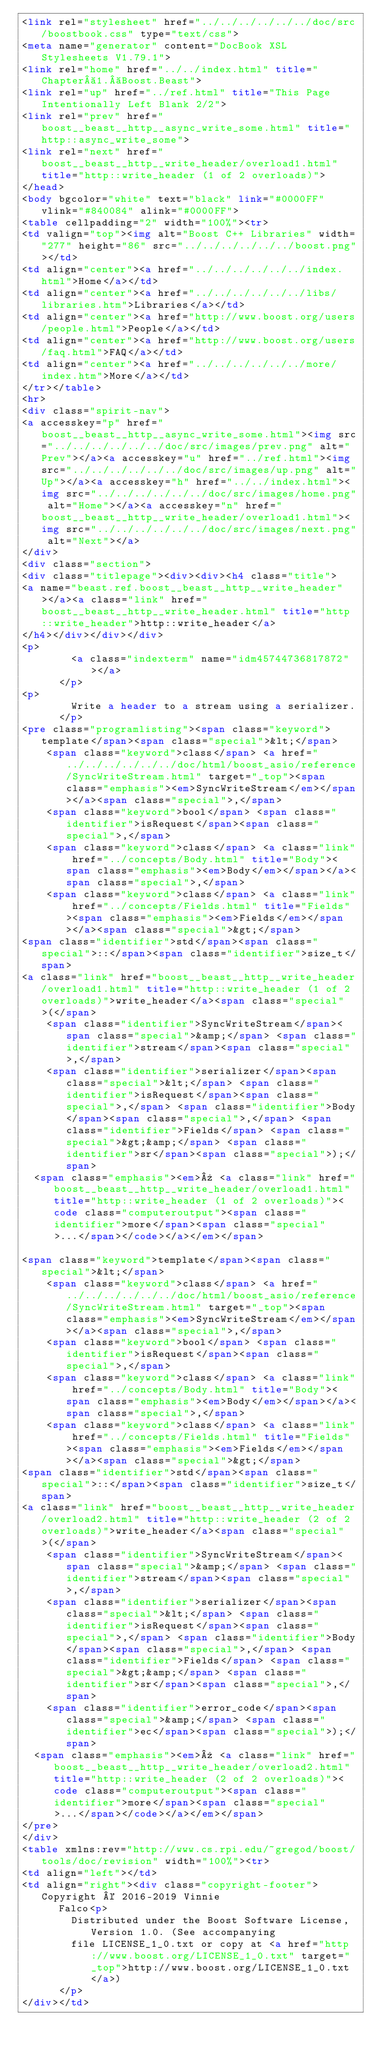Convert code to text. <code><loc_0><loc_0><loc_500><loc_500><_HTML_><link rel="stylesheet" href="../../../../../../doc/src/boostbook.css" type="text/css">
<meta name="generator" content="DocBook XSL Stylesheets V1.79.1">
<link rel="home" href="../../index.html" title="Chapter 1. Boost.Beast">
<link rel="up" href="../ref.html" title="This Page Intentionally Left Blank 2/2">
<link rel="prev" href="boost__beast__http__async_write_some.html" title="http::async_write_some">
<link rel="next" href="boost__beast__http__write_header/overload1.html" title="http::write_header (1 of 2 overloads)">
</head>
<body bgcolor="white" text="black" link="#0000FF" vlink="#840084" alink="#0000FF">
<table cellpadding="2" width="100%"><tr>
<td valign="top"><img alt="Boost C++ Libraries" width="277" height="86" src="../../../../../../boost.png"></td>
<td align="center"><a href="../../../../../../index.html">Home</a></td>
<td align="center"><a href="../../../../../../libs/libraries.htm">Libraries</a></td>
<td align="center"><a href="http://www.boost.org/users/people.html">People</a></td>
<td align="center"><a href="http://www.boost.org/users/faq.html">FAQ</a></td>
<td align="center"><a href="../../../../../../more/index.htm">More</a></td>
</tr></table>
<hr>
<div class="spirit-nav">
<a accesskey="p" href="boost__beast__http__async_write_some.html"><img src="../../../../../../doc/src/images/prev.png" alt="Prev"></a><a accesskey="u" href="../ref.html"><img src="../../../../../../doc/src/images/up.png" alt="Up"></a><a accesskey="h" href="../../index.html"><img src="../../../../../../doc/src/images/home.png" alt="Home"></a><a accesskey="n" href="boost__beast__http__write_header/overload1.html"><img src="../../../../../../doc/src/images/next.png" alt="Next"></a>
</div>
<div class="section">
<div class="titlepage"><div><div><h4 class="title">
<a name="beast.ref.boost__beast__http__write_header"></a><a class="link" href="boost__beast__http__write_header.html" title="http::write_header">http::write_header</a>
</h4></div></div></div>
<p>
        <a class="indexterm" name="idm45744736817872"></a>
      </p>
<p>
        Write a header to a stream using a serializer.
      </p>
<pre class="programlisting"><span class="keyword">template</span><span class="special">&lt;</span>
    <span class="keyword">class</span> <a href="../../../../../../doc/html/boost_asio/reference/SyncWriteStream.html" target="_top"><span class="emphasis"><em>SyncWriteStream</em></span></a><span class="special">,</span>
    <span class="keyword">bool</span> <span class="identifier">isRequest</span><span class="special">,</span>
    <span class="keyword">class</span> <a class="link" href="../concepts/Body.html" title="Body"><span class="emphasis"><em>Body</em></span></a><span class="special">,</span>
    <span class="keyword">class</span> <a class="link" href="../concepts/Fields.html" title="Fields"><span class="emphasis"><em>Fields</em></span></a><span class="special">&gt;</span>
<span class="identifier">std</span><span class="special">::</span><span class="identifier">size_t</span>
<a class="link" href="boost__beast__http__write_header/overload1.html" title="http::write_header (1 of 2 overloads)">write_header</a><span class="special">(</span>
    <span class="identifier">SyncWriteStream</span><span class="special">&amp;</span> <span class="identifier">stream</span><span class="special">,</span>
    <span class="identifier">serializer</span><span class="special">&lt;</span> <span class="identifier">isRequest</span><span class="special">,</span> <span class="identifier">Body</span><span class="special">,</span> <span class="identifier">Fields</span> <span class="special">&gt;&amp;</span> <span class="identifier">sr</span><span class="special">);</span>
  <span class="emphasis"><em>» <a class="link" href="boost__beast__http__write_header/overload1.html" title="http::write_header (1 of 2 overloads)"><code class="computeroutput"><span class="identifier">more</span><span class="special">...</span></code></a></em></span>

<span class="keyword">template</span><span class="special">&lt;</span>
    <span class="keyword">class</span> <a href="../../../../../../doc/html/boost_asio/reference/SyncWriteStream.html" target="_top"><span class="emphasis"><em>SyncWriteStream</em></span></a><span class="special">,</span>
    <span class="keyword">bool</span> <span class="identifier">isRequest</span><span class="special">,</span>
    <span class="keyword">class</span> <a class="link" href="../concepts/Body.html" title="Body"><span class="emphasis"><em>Body</em></span></a><span class="special">,</span>
    <span class="keyword">class</span> <a class="link" href="../concepts/Fields.html" title="Fields"><span class="emphasis"><em>Fields</em></span></a><span class="special">&gt;</span>
<span class="identifier">std</span><span class="special">::</span><span class="identifier">size_t</span>
<a class="link" href="boost__beast__http__write_header/overload2.html" title="http::write_header (2 of 2 overloads)">write_header</a><span class="special">(</span>
    <span class="identifier">SyncWriteStream</span><span class="special">&amp;</span> <span class="identifier">stream</span><span class="special">,</span>
    <span class="identifier">serializer</span><span class="special">&lt;</span> <span class="identifier">isRequest</span><span class="special">,</span> <span class="identifier">Body</span><span class="special">,</span> <span class="identifier">Fields</span> <span class="special">&gt;&amp;</span> <span class="identifier">sr</span><span class="special">,</span>
    <span class="identifier">error_code</span><span class="special">&amp;</span> <span class="identifier">ec</span><span class="special">);</span>
  <span class="emphasis"><em>» <a class="link" href="boost__beast__http__write_header/overload2.html" title="http::write_header (2 of 2 overloads)"><code class="computeroutput"><span class="identifier">more</span><span class="special">...</span></code></a></em></span>
</pre>
</div>
<table xmlns:rev="http://www.cs.rpi.edu/~gregod/boost/tools/doc/revision" width="100%"><tr>
<td align="left"></td>
<td align="right"><div class="copyright-footer">Copyright © 2016-2019 Vinnie
      Falco<p>
        Distributed under the Boost Software License, Version 1.0. (See accompanying
        file LICENSE_1_0.txt or copy at <a href="http://www.boost.org/LICENSE_1_0.txt" target="_top">http://www.boost.org/LICENSE_1_0.txt</a>)
      </p>
</div></td></code> 